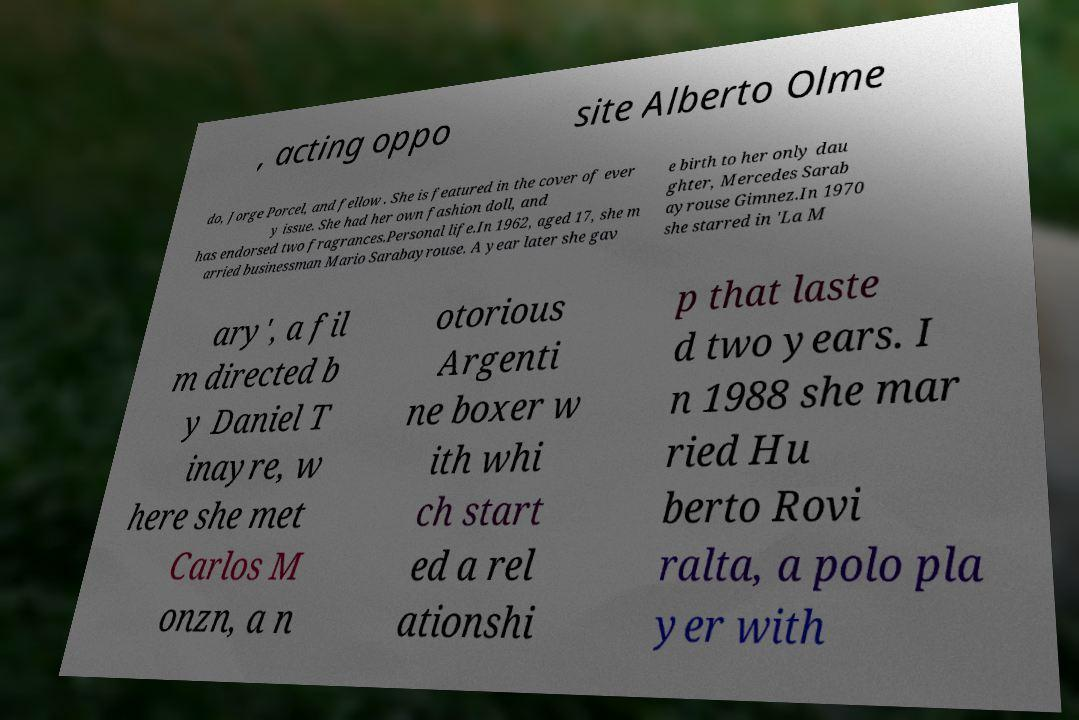Can you accurately transcribe the text from the provided image for me? , acting oppo site Alberto Olme do, Jorge Porcel, and fellow . She is featured in the cover of ever y issue. She had her own fashion doll, and has endorsed two fragrances.Personal life.In 1962, aged 17, she m arried businessman Mario Sarabayrouse. A year later she gav e birth to her only dau ghter, Mercedes Sarab ayrouse Gimnez.In 1970 she starred in 'La M ary', a fil m directed b y Daniel T inayre, w here she met Carlos M onzn, a n otorious Argenti ne boxer w ith whi ch start ed a rel ationshi p that laste d two years. I n 1988 she mar ried Hu berto Rovi ralta, a polo pla yer with 